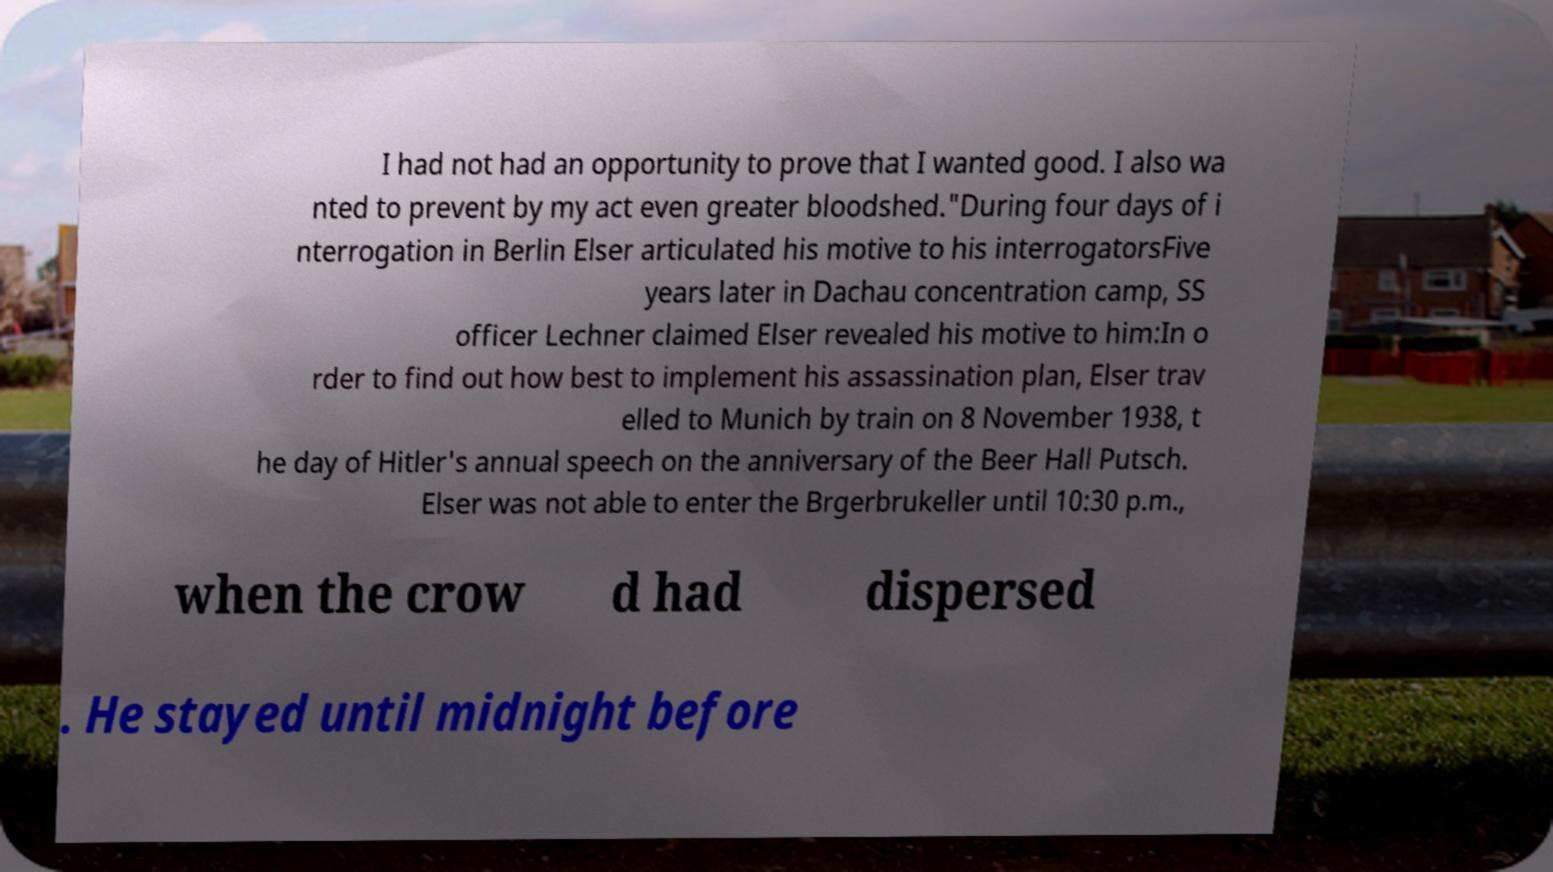For documentation purposes, I need the text within this image transcribed. Could you provide that? I had not had an opportunity to prove that I wanted good. I also wa nted to prevent by my act even greater bloodshed."During four days of i nterrogation in Berlin Elser articulated his motive to his interrogatorsFive years later in Dachau concentration camp, SS officer Lechner claimed Elser revealed his motive to him:In o rder to find out how best to implement his assassination plan, Elser trav elled to Munich by train on 8 November 1938, t he day of Hitler's annual speech on the anniversary of the Beer Hall Putsch. Elser was not able to enter the Brgerbrukeller until 10:30 p.m., when the crow d had dispersed . He stayed until midnight before 